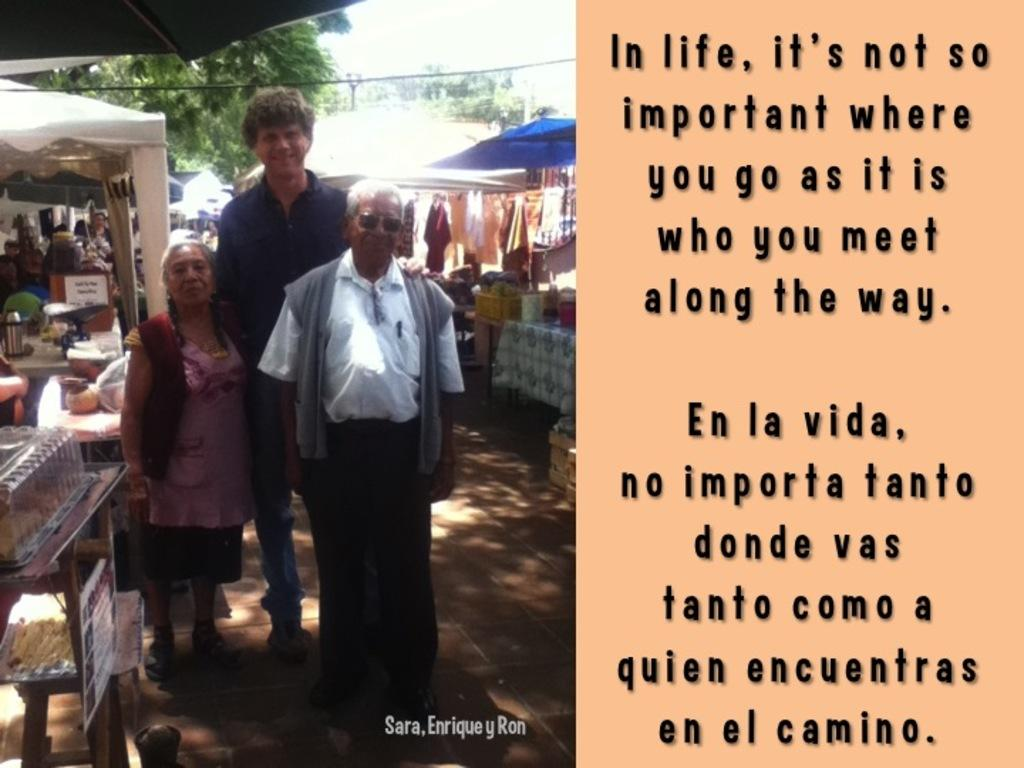What can be found on the right side of the image? There is text on the right side of the image. What is located on the left side of the image? There are stores, clothes, umbrellas, and trees on the left side of the image. What is visible in the sky in the image? The sky is visible in the image. What type of jeans can be seen on the farm in the image? There is no farm or jeans present in the image. What is the learning environment like in the image? The image does not depict a learning environment; it features text, stores, clothes, umbrellas, trees, and the sky. 